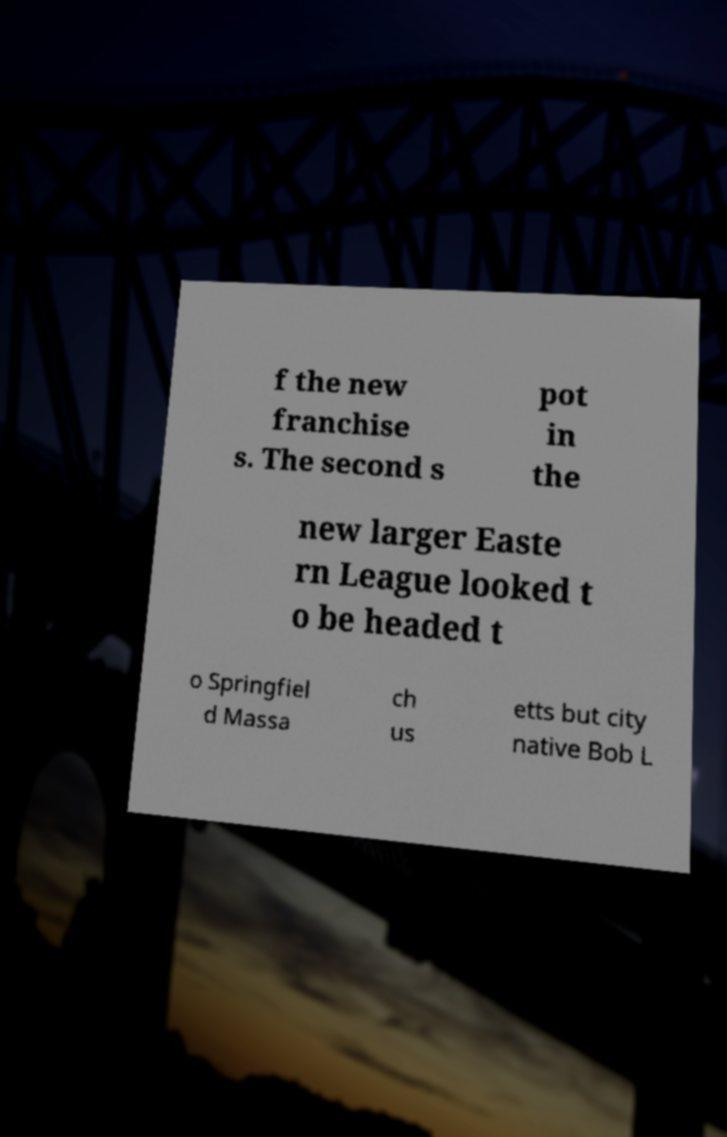Please identify and transcribe the text found in this image. f the new franchise s. The second s pot in the new larger Easte rn League looked t o be headed t o Springfiel d Massa ch us etts but city native Bob L 